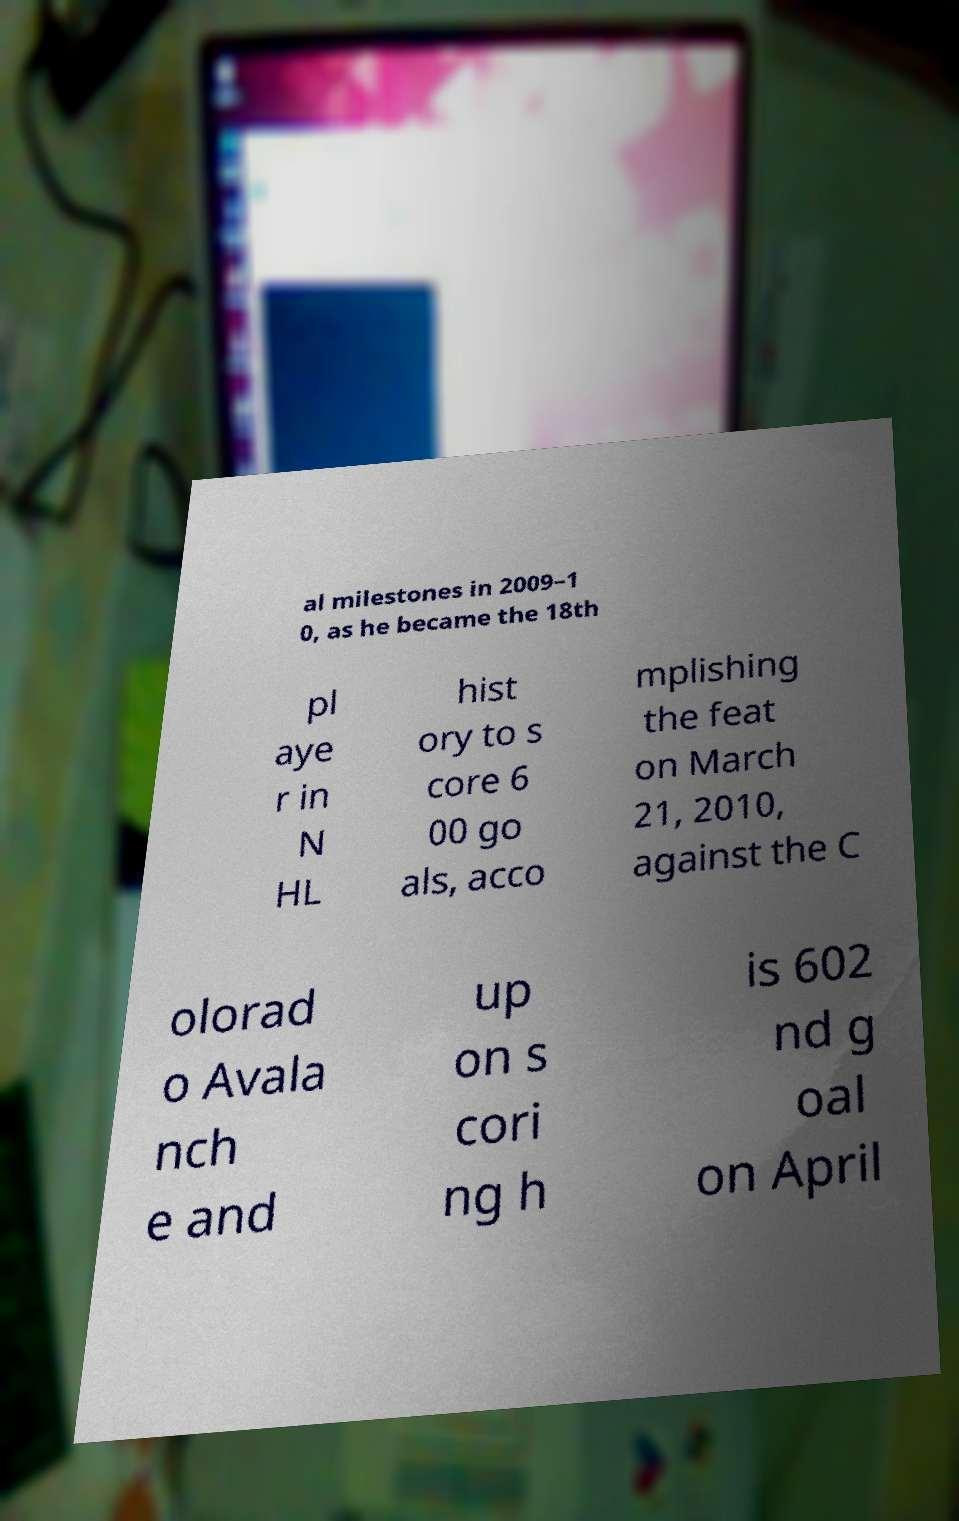Could you assist in decoding the text presented in this image and type it out clearly? al milestones in 2009–1 0, as he became the 18th pl aye r in N HL hist ory to s core 6 00 go als, acco mplishing the feat on March 21, 2010, against the C olorad o Avala nch e and up on s cori ng h is 602 nd g oal on April 